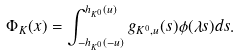Convert formula to latex. <formula><loc_0><loc_0><loc_500><loc_500>\Phi _ { K } ( x ) = \int _ { - h _ { K ^ { 0 } } ( - u ) } ^ { h _ { K ^ { 0 } } ( u ) } g _ { K ^ { 0 } , u } ( s ) \phi ( \lambda s ) d s .</formula> 